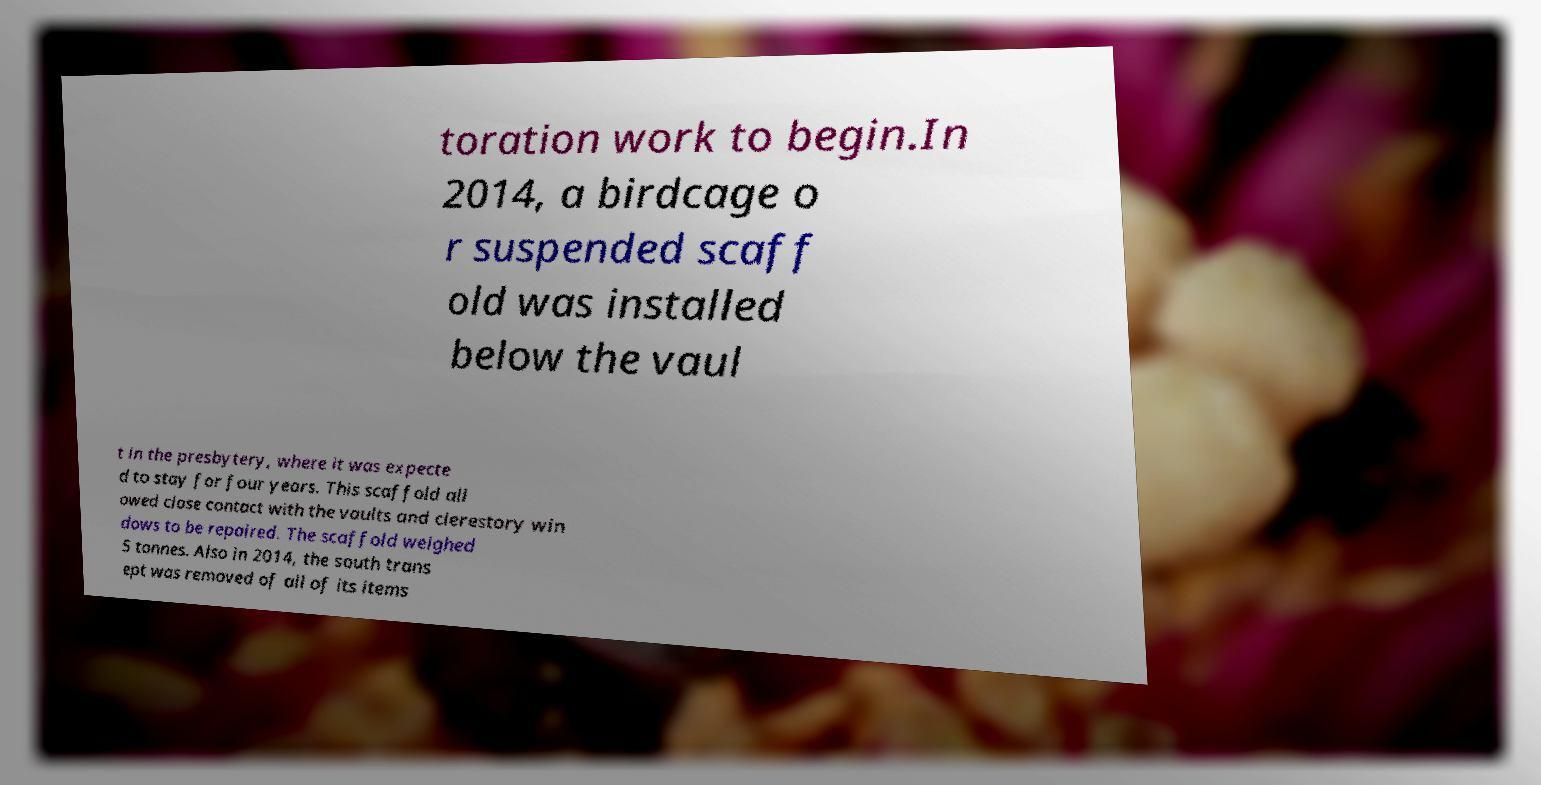What messages or text are displayed in this image? I need them in a readable, typed format. toration work to begin.In 2014, a birdcage o r suspended scaff old was installed below the vaul t in the presbytery, where it was expecte d to stay for four years. This scaffold all owed close contact with the vaults and clerestory win dows to be repaired. The scaffold weighed 5 tonnes. Also in 2014, the south trans ept was removed of all of its items 